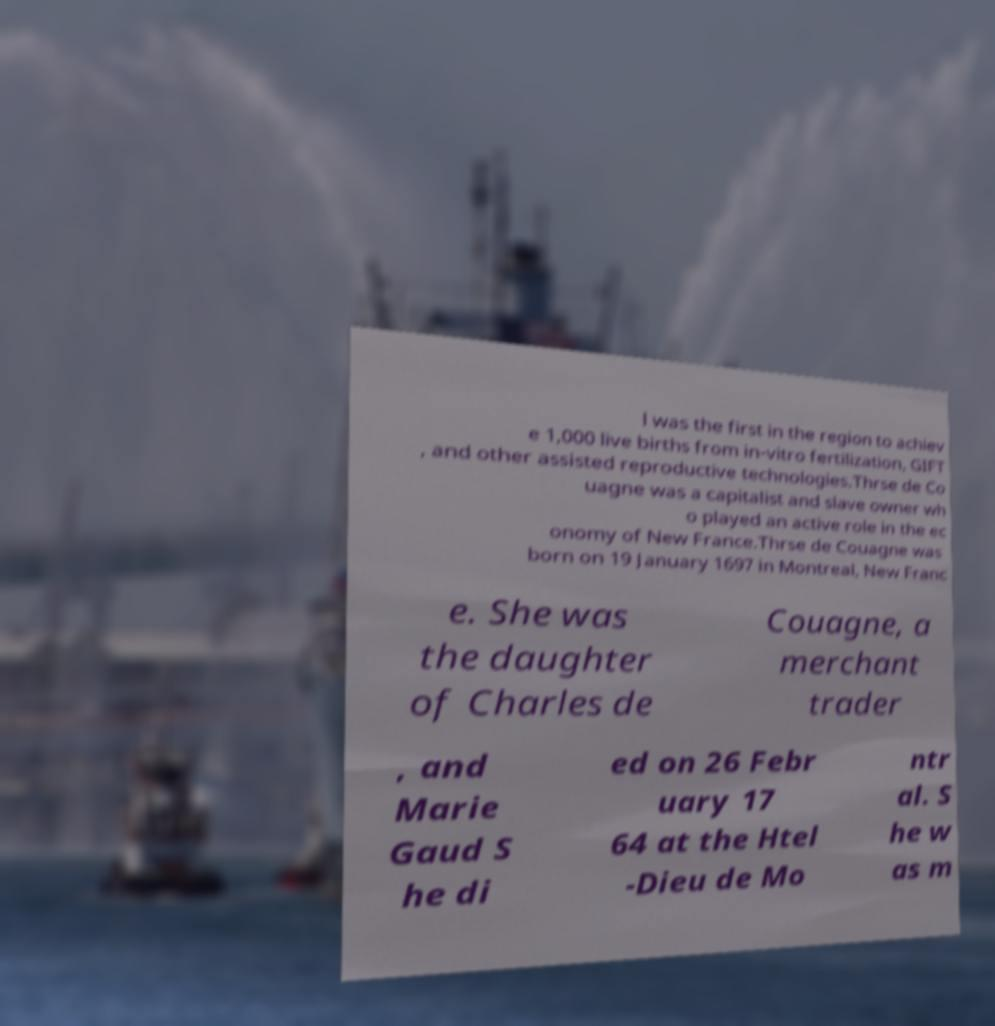I need the written content from this picture converted into text. Can you do that? l was the first in the region to achiev e 1,000 live births from in-vitro fertilization, GIFT , and other assisted reproductive technologies.Thrse de Co uagne was a capitalist and slave owner wh o played an active role in the ec onomy of New France.Thrse de Couagne was born on 19 January 1697 in Montreal, New Franc e. She was the daughter of Charles de Couagne, a merchant trader , and Marie Gaud S he di ed on 26 Febr uary 17 64 at the Htel -Dieu de Mo ntr al. S he w as m 